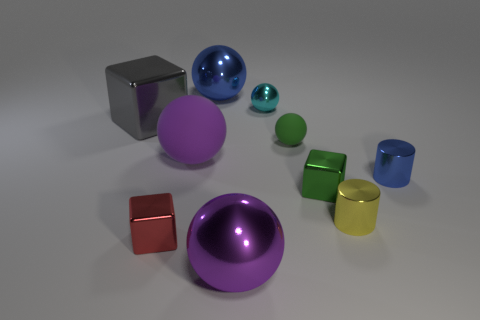What number of big purple metallic objects are left of the tiny block to the left of the rubber object that is to the left of the green sphere?
Your response must be concise. 0. Is the shape of the small red shiny thing the same as the gray metal object?
Make the answer very short. Yes. Is there a green object of the same shape as the tiny cyan object?
Offer a terse response. Yes. What is the shape of the yellow object that is the same size as the red cube?
Make the answer very short. Cylinder. What is the green thing that is behind the big purple ball that is behind the small shiny cube that is to the left of the purple shiny sphere made of?
Your answer should be very brief. Rubber. Is the gray metallic block the same size as the purple matte sphere?
Offer a terse response. Yes. What material is the small blue cylinder?
Provide a short and direct response. Metal. Is the shape of the blue thing on the left side of the cyan metallic thing the same as  the yellow thing?
Your answer should be very brief. No. How many things are blue metallic spheres or green metallic objects?
Your response must be concise. 2. Do the large thing that is behind the gray metallic thing and the small yellow thing have the same material?
Make the answer very short. Yes. 